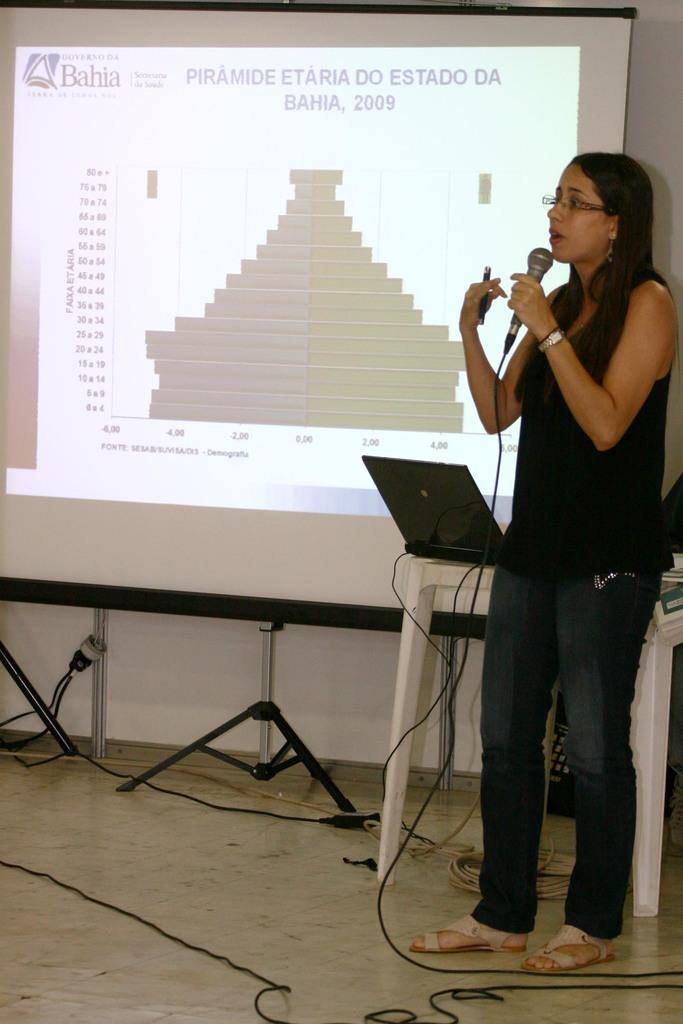Who is the main subject in the foreground of the image? There is a woman in the foreground of the image. What is the woman holding in her hand? The woman is holding a microphone in her hand. What surface is the woman standing on? The woman is standing on the floor. What can be seen in the background of the image? There is a table, a laptop, and a screen in the background of the image. Where was the image taken? The image was taken in a hall. What type of lettuce is being used as a prop on the table in the image? There is no lettuce present in the image; it features a woman holding a microphone, a table with a laptop, and a screen in the background. 